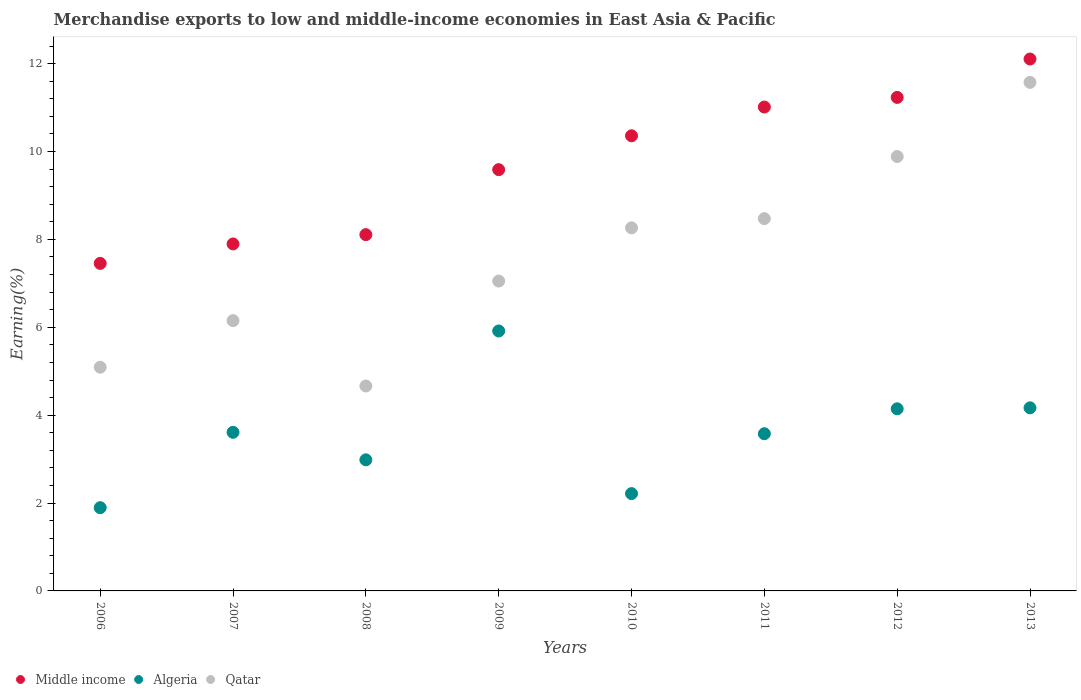Is the number of dotlines equal to the number of legend labels?
Provide a short and direct response. Yes. What is the percentage of amount earned from merchandise exports in Middle income in 2008?
Your answer should be compact. 8.11. Across all years, what is the maximum percentage of amount earned from merchandise exports in Algeria?
Provide a succinct answer. 5.92. Across all years, what is the minimum percentage of amount earned from merchandise exports in Algeria?
Your response must be concise. 1.9. In which year was the percentage of amount earned from merchandise exports in Algeria minimum?
Keep it short and to the point. 2006. What is the total percentage of amount earned from merchandise exports in Qatar in the graph?
Your answer should be compact. 61.16. What is the difference between the percentage of amount earned from merchandise exports in Algeria in 2012 and that in 2013?
Ensure brevity in your answer.  -0.02. What is the difference between the percentage of amount earned from merchandise exports in Qatar in 2007 and the percentage of amount earned from merchandise exports in Algeria in 2009?
Your response must be concise. 0.24. What is the average percentage of amount earned from merchandise exports in Qatar per year?
Keep it short and to the point. 7.64. In the year 2009, what is the difference between the percentage of amount earned from merchandise exports in Algeria and percentage of amount earned from merchandise exports in Qatar?
Your answer should be very brief. -1.14. In how many years, is the percentage of amount earned from merchandise exports in Algeria greater than 10.4 %?
Your answer should be very brief. 0. What is the ratio of the percentage of amount earned from merchandise exports in Middle income in 2009 to that in 2010?
Your answer should be very brief. 0.93. What is the difference between the highest and the second highest percentage of amount earned from merchandise exports in Middle income?
Keep it short and to the point. 0.87. What is the difference between the highest and the lowest percentage of amount earned from merchandise exports in Algeria?
Keep it short and to the point. 4.02. In how many years, is the percentage of amount earned from merchandise exports in Middle income greater than the average percentage of amount earned from merchandise exports in Middle income taken over all years?
Your answer should be very brief. 4. Is the sum of the percentage of amount earned from merchandise exports in Qatar in 2007 and 2013 greater than the maximum percentage of amount earned from merchandise exports in Algeria across all years?
Give a very brief answer. Yes. Is it the case that in every year, the sum of the percentage of amount earned from merchandise exports in Middle income and percentage of amount earned from merchandise exports in Qatar  is greater than the percentage of amount earned from merchandise exports in Algeria?
Your answer should be very brief. Yes. How many dotlines are there?
Make the answer very short. 3. How many years are there in the graph?
Your answer should be very brief. 8. Are the values on the major ticks of Y-axis written in scientific E-notation?
Provide a short and direct response. No. Does the graph contain grids?
Your response must be concise. No. Where does the legend appear in the graph?
Provide a short and direct response. Bottom left. What is the title of the graph?
Your response must be concise. Merchandise exports to low and middle-income economies in East Asia & Pacific. What is the label or title of the X-axis?
Ensure brevity in your answer.  Years. What is the label or title of the Y-axis?
Offer a very short reply. Earning(%). What is the Earning(%) of Middle income in 2006?
Keep it short and to the point. 7.45. What is the Earning(%) in Algeria in 2006?
Offer a very short reply. 1.9. What is the Earning(%) of Qatar in 2006?
Ensure brevity in your answer.  5.09. What is the Earning(%) in Middle income in 2007?
Provide a short and direct response. 7.9. What is the Earning(%) in Algeria in 2007?
Make the answer very short. 3.61. What is the Earning(%) in Qatar in 2007?
Provide a short and direct response. 6.15. What is the Earning(%) of Middle income in 2008?
Offer a terse response. 8.11. What is the Earning(%) of Algeria in 2008?
Make the answer very short. 2.98. What is the Earning(%) in Qatar in 2008?
Offer a terse response. 4.66. What is the Earning(%) of Middle income in 2009?
Keep it short and to the point. 9.59. What is the Earning(%) in Algeria in 2009?
Provide a short and direct response. 5.92. What is the Earning(%) of Qatar in 2009?
Provide a short and direct response. 7.05. What is the Earning(%) of Middle income in 2010?
Provide a short and direct response. 10.36. What is the Earning(%) in Algeria in 2010?
Keep it short and to the point. 2.21. What is the Earning(%) of Qatar in 2010?
Ensure brevity in your answer.  8.26. What is the Earning(%) in Middle income in 2011?
Ensure brevity in your answer.  11.01. What is the Earning(%) of Algeria in 2011?
Your answer should be very brief. 3.58. What is the Earning(%) of Qatar in 2011?
Provide a succinct answer. 8.47. What is the Earning(%) of Middle income in 2012?
Provide a succinct answer. 11.23. What is the Earning(%) of Algeria in 2012?
Make the answer very short. 4.15. What is the Earning(%) of Qatar in 2012?
Your answer should be compact. 9.89. What is the Earning(%) in Middle income in 2013?
Provide a short and direct response. 12.11. What is the Earning(%) in Algeria in 2013?
Your answer should be compact. 4.17. What is the Earning(%) in Qatar in 2013?
Give a very brief answer. 11.57. Across all years, what is the maximum Earning(%) in Middle income?
Offer a terse response. 12.11. Across all years, what is the maximum Earning(%) in Algeria?
Your response must be concise. 5.92. Across all years, what is the maximum Earning(%) in Qatar?
Your answer should be compact. 11.57. Across all years, what is the minimum Earning(%) in Middle income?
Your answer should be very brief. 7.45. Across all years, what is the minimum Earning(%) of Algeria?
Your answer should be compact. 1.9. Across all years, what is the minimum Earning(%) of Qatar?
Ensure brevity in your answer.  4.66. What is the total Earning(%) in Middle income in the graph?
Offer a very short reply. 77.76. What is the total Earning(%) in Algeria in the graph?
Provide a succinct answer. 28.51. What is the total Earning(%) in Qatar in the graph?
Provide a succinct answer. 61.16. What is the difference between the Earning(%) of Middle income in 2006 and that in 2007?
Offer a very short reply. -0.44. What is the difference between the Earning(%) of Algeria in 2006 and that in 2007?
Your response must be concise. -1.72. What is the difference between the Earning(%) in Qatar in 2006 and that in 2007?
Ensure brevity in your answer.  -1.06. What is the difference between the Earning(%) of Middle income in 2006 and that in 2008?
Ensure brevity in your answer.  -0.65. What is the difference between the Earning(%) in Algeria in 2006 and that in 2008?
Your answer should be very brief. -1.09. What is the difference between the Earning(%) of Qatar in 2006 and that in 2008?
Ensure brevity in your answer.  0.43. What is the difference between the Earning(%) of Middle income in 2006 and that in 2009?
Keep it short and to the point. -2.13. What is the difference between the Earning(%) of Algeria in 2006 and that in 2009?
Ensure brevity in your answer.  -4.02. What is the difference between the Earning(%) of Qatar in 2006 and that in 2009?
Provide a succinct answer. -1.96. What is the difference between the Earning(%) of Middle income in 2006 and that in 2010?
Your answer should be very brief. -2.9. What is the difference between the Earning(%) of Algeria in 2006 and that in 2010?
Your response must be concise. -0.32. What is the difference between the Earning(%) of Qatar in 2006 and that in 2010?
Your answer should be compact. -3.17. What is the difference between the Earning(%) in Middle income in 2006 and that in 2011?
Offer a terse response. -3.56. What is the difference between the Earning(%) of Algeria in 2006 and that in 2011?
Provide a succinct answer. -1.68. What is the difference between the Earning(%) in Qatar in 2006 and that in 2011?
Give a very brief answer. -3.38. What is the difference between the Earning(%) of Middle income in 2006 and that in 2012?
Make the answer very short. -3.78. What is the difference between the Earning(%) of Algeria in 2006 and that in 2012?
Provide a short and direct response. -2.25. What is the difference between the Earning(%) of Qatar in 2006 and that in 2012?
Keep it short and to the point. -4.8. What is the difference between the Earning(%) of Middle income in 2006 and that in 2013?
Offer a terse response. -4.65. What is the difference between the Earning(%) of Algeria in 2006 and that in 2013?
Your answer should be compact. -2.27. What is the difference between the Earning(%) in Qatar in 2006 and that in 2013?
Your response must be concise. -6.48. What is the difference between the Earning(%) of Middle income in 2007 and that in 2008?
Offer a very short reply. -0.21. What is the difference between the Earning(%) of Algeria in 2007 and that in 2008?
Ensure brevity in your answer.  0.63. What is the difference between the Earning(%) in Qatar in 2007 and that in 2008?
Keep it short and to the point. 1.49. What is the difference between the Earning(%) in Middle income in 2007 and that in 2009?
Keep it short and to the point. -1.69. What is the difference between the Earning(%) of Algeria in 2007 and that in 2009?
Provide a succinct answer. -2.31. What is the difference between the Earning(%) in Qatar in 2007 and that in 2009?
Your answer should be very brief. -0.9. What is the difference between the Earning(%) in Middle income in 2007 and that in 2010?
Make the answer very short. -2.46. What is the difference between the Earning(%) in Algeria in 2007 and that in 2010?
Give a very brief answer. 1.4. What is the difference between the Earning(%) of Qatar in 2007 and that in 2010?
Make the answer very short. -2.11. What is the difference between the Earning(%) of Middle income in 2007 and that in 2011?
Give a very brief answer. -3.12. What is the difference between the Earning(%) in Algeria in 2007 and that in 2011?
Offer a terse response. 0.03. What is the difference between the Earning(%) of Qatar in 2007 and that in 2011?
Provide a succinct answer. -2.32. What is the difference between the Earning(%) of Middle income in 2007 and that in 2012?
Ensure brevity in your answer.  -3.33. What is the difference between the Earning(%) in Algeria in 2007 and that in 2012?
Keep it short and to the point. -0.54. What is the difference between the Earning(%) of Qatar in 2007 and that in 2012?
Ensure brevity in your answer.  -3.74. What is the difference between the Earning(%) of Middle income in 2007 and that in 2013?
Make the answer very short. -4.21. What is the difference between the Earning(%) in Algeria in 2007 and that in 2013?
Your answer should be very brief. -0.56. What is the difference between the Earning(%) in Qatar in 2007 and that in 2013?
Provide a succinct answer. -5.42. What is the difference between the Earning(%) in Middle income in 2008 and that in 2009?
Your response must be concise. -1.48. What is the difference between the Earning(%) in Algeria in 2008 and that in 2009?
Give a very brief answer. -2.93. What is the difference between the Earning(%) in Qatar in 2008 and that in 2009?
Ensure brevity in your answer.  -2.39. What is the difference between the Earning(%) of Middle income in 2008 and that in 2010?
Your answer should be very brief. -2.25. What is the difference between the Earning(%) of Algeria in 2008 and that in 2010?
Make the answer very short. 0.77. What is the difference between the Earning(%) of Qatar in 2008 and that in 2010?
Your answer should be very brief. -3.6. What is the difference between the Earning(%) in Middle income in 2008 and that in 2011?
Offer a terse response. -2.9. What is the difference between the Earning(%) in Algeria in 2008 and that in 2011?
Your answer should be very brief. -0.59. What is the difference between the Earning(%) of Qatar in 2008 and that in 2011?
Your answer should be compact. -3.81. What is the difference between the Earning(%) of Middle income in 2008 and that in 2012?
Provide a short and direct response. -3.12. What is the difference between the Earning(%) in Algeria in 2008 and that in 2012?
Offer a terse response. -1.16. What is the difference between the Earning(%) in Qatar in 2008 and that in 2012?
Provide a short and direct response. -5.22. What is the difference between the Earning(%) of Middle income in 2008 and that in 2013?
Your answer should be compact. -4. What is the difference between the Earning(%) in Algeria in 2008 and that in 2013?
Provide a short and direct response. -1.18. What is the difference between the Earning(%) of Qatar in 2008 and that in 2013?
Your response must be concise. -6.91. What is the difference between the Earning(%) in Middle income in 2009 and that in 2010?
Offer a very short reply. -0.77. What is the difference between the Earning(%) in Algeria in 2009 and that in 2010?
Your answer should be very brief. 3.7. What is the difference between the Earning(%) in Qatar in 2009 and that in 2010?
Give a very brief answer. -1.21. What is the difference between the Earning(%) in Middle income in 2009 and that in 2011?
Provide a succinct answer. -1.42. What is the difference between the Earning(%) of Algeria in 2009 and that in 2011?
Give a very brief answer. 2.34. What is the difference between the Earning(%) of Qatar in 2009 and that in 2011?
Provide a succinct answer. -1.42. What is the difference between the Earning(%) of Middle income in 2009 and that in 2012?
Offer a very short reply. -1.64. What is the difference between the Earning(%) in Algeria in 2009 and that in 2012?
Your response must be concise. 1.77. What is the difference between the Earning(%) of Qatar in 2009 and that in 2012?
Your answer should be compact. -2.83. What is the difference between the Earning(%) in Middle income in 2009 and that in 2013?
Ensure brevity in your answer.  -2.52. What is the difference between the Earning(%) of Algeria in 2009 and that in 2013?
Your answer should be very brief. 1.75. What is the difference between the Earning(%) in Qatar in 2009 and that in 2013?
Ensure brevity in your answer.  -4.52. What is the difference between the Earning(%) in Middle income in 2010 and that in 2011?
Ensure brevity in your answer.  -0.65. What is the difference between the Earning(%) of Algeria in 2010 and that in 2011?
Make the answer very short. -1.36. What is the difference between the Earning(%) in Qatar in 2010 and that in 2011?
Keep it short and to the point. -0.21. What is the difference between the Earning(%) in Middle income in 2010 and that in 2012?
Keep it short and to the point. -0.87. What is the difference between the Earning(%) of Algeria in 2010 and that in 2012?
Provide a succinct answer. -1.93. What is the difference between the Earning(%) in Qatar in 2010 and that in 2012?
Your response must be concise. -1.62. What is the difference between the Earning(%) of Middle income in 2010 and that in 2013?
Provide a short and direct response. -1.75. What is the difference between the Earning(%) in Algeria in 2010 and that in 2013?
Offer a very short reply. -1.95. What is the difference between the Earning(%) of Qatar in 2010 and that in 2013?
Your answer should be very brief. -3.31. What is the difference between the Earning(%) of Middle income in 2011 and that in 2012?
Your response must be concise. -0.22. What is the difference between the Earning(%) of Algeria in 2011 and that in 2012?
Keep it short and to the point. -0.57. What is the difference between the Earning(%) in Qatar in 2011 and that in 2012?
Ensure brevity in your answer.  -1.41. What is the difference between the Earning(%) of Middle income in 2011 and that in 2013?
Offer a very short reply. -1.09. What is the difference between the Earning(%) in Algeria in 2011 and that in 2013?
Offer a very short reply. -0.59. What is the difference between the Earning(%) in Qatar in 2011 and that in 2013?
Offer a terse response. -3.1. What is the difference between the Earning(%) in Middle income in 2012 and that in 2013?
Provide a succinct answer. -0.87. What is the difference between the Earning(%) in Algeria in 2012 and that in 2013?
Provide a succinct answer. -0.02. What is the difference between the Earning(%) of Qatar in 2012 and that in 2013?
Offer a terse response. -1.69. What is the difference between the Earning(%) in Middle income in 2006 and the Earning(%) in Algeria in 2007?
Provide a succinct answer. 3.84. What is the difference between the Earning(%) in Middle income in 2006 and the Earning(%) in Qatar in 2007?
Provide a short and direct response. 1.3. What is the difference between the Earning(%) in Algeria in 2006 and the Earning(%) in Qatar in 2007?
Your answer should be very brief. -4.26. What is the difference between the Earning(%) in Middle income in 2006 and the Earning(%) in Algeria in 2008?
Offer a very short reply. 4.47. What is the difference between the Earning(%) in Middle income in 2006 and the Earning(%) in Qatar in 2008?
Ensure brevity in your answer.  2.79. What is the difference between the Earning(%) of Algeria in 2006 and the Earning(%) of Qatar in 2008?
Your answer should be compact. -2.77. What is the difference between the Earning(%) of Middle income in 2006 and the Earning(%) of Algeria in 2009?
Make the answer very short. 1.54. What is the difference between the Earning(%) of Middle income in 2006 and the Earning(%) of Qatar in 2009?
Provide a succinct answer. 0.4. What is the difference between the Earning(%) of Algeria in 2006 and the Earning(%) of Qatar in 2009?
Keep it short and to the point. -5.16. What is the difference between the Earning(%) of Middle income in 2006 and the Earning(%) of Algeria in 2010?
Offer a terse response. 5.24. What is the difference between the Earning(%) of Middle income in 2006 and the Earning(%) of Qatar in 2010?
Keep it short and to the point. -0.81. What is the difference between the Earning(%) in Algeria in 2006 and the Earning(%) in Qatar in 2010?
Your answer should be compact. -6.37. What is the difference between the Earning(%) of Middle income in 2006 and the Earning(%) of Algeria in 2011?
Your response must be concise. 3.88. What is the difference between the Earning(%) in Middle income in 2006 and the Earning(%) in Qatar in 2011?
Provide a short and direct response. -1.02. What is the difference between the Earning(%) of Algeria in 2006 and the Earning(%) of Qatar in 2011?
Your answer should be compact. -6.58. What is the difference between the Earning(%) of Middle income in 2006 and the Earning(%) of Algeria in 2012?
Your response must be concise. 3.31. What is the difference between the Earning(%) of Middle income in 2006 and the Earning(%) of Qatar in 2012?
Provide a succinct answer. -2.43. What is the difference between the Earning(%) in Algeria in 2006 and the Earning(%) in Qatar in 2012?
Your response must be concise. -7.99. What is the difference between the Earning(%) in Middle income in 2006 and the Earning(%) in Algeria in 2013?
Offer a terse response. 3.29. What is the difference between the Earning(%) of Middle income in 2006 and the Earning(%) of Qatar in 2013?
Offer a very short reply. -4.12. What is the difference between the Earning(%) of Algeria in 2006 and the Earning(%) of Qatar in 2013?
Ensure brevity in your answer.  -9.68. What is the difference between the Earning(%) of Middle income in 2007 and the Earning(%) of Algeria in 2008?
Ensure brevity in your answer.  4.91. What is the difference between the Earning(%) of Middle income in 2007 and the Earning(%) of Qatar in 2008?
Give a very brief answer. 3.23. What is the difference between the Earning(%) in Algeria in 2007 and the Earning(%) in Qatar in 2008?
Give a very brief answer. -1.05. What is the difference between the Earning(%) of Middle income in 2007 and the Earning(%) of Algeria in 2009?
Your answer should be very brief. 1.98. What is the difference between the Earning(%) in Middle income in 2007 and the Earning(%) in Qatar in 2009?
Provide a succinct answer. 0.84. What is the difference between the Earning(%) of Algeria in 2007 and the Earning(%) of Qatar in 2009?
Your response must be concise. -3.44. What is the difference between the Earning(%) of Middle income in 2007 and the Earning(%) of Algeria in 2010?
Provide a succinct answer. 5.68. What is the difference between the Earning(%) in Middle income in 2007 and the Earning(%) in Qatar in 2010?
Make the answer very short. -0.37. What is the difference between the Earning(%) in Algeria in 2007 and the Earning(%) in Qatar in 2010?
Make the answer very short. -4.65. What is the difference between the Earning(%) in Middle income in 2007 and the Earning(%) in Algeria in 2011?
Keep it short and to the point. 4.32. What is the difference between the Earning(%) in Middle income in 2007 and the Earning(%) in Qatar in 2011?
Ensure brevity in your answer.  -0.58. What is the difference between the Earning(%) in Algeria in 2007 and the Earning(%) in Qatar in 2011?
Your answer should be very brief. -4.86. What is the difference between the Earning(%) in Middle income in 2007 and the Earning(%) in Algeria in 2012?
Your answer should be compact. 3.75. What is the difference between the Earning(%) of Middle income in 2007 and the Earning(%) of Qatar in 2012?
Your answer should be compact. -1.99. What is the difference between the Earning(%) of Algeria in 2007 and the Earning(%) of Qatar in 2012?
Provide a succinct answer. -6.28. What is the difference between the Earning(%) of Middle income in 2007 and the Earning(%) of Algeria in 2013?
Provide a short and direct response. 3.73. What is the difference between the Earning(%) of Middle income in 2007 and the Earning(%) of Qatar in 2013?
Your answer should be compact. -3.68. What is the difference between the Earning(%) of Algeria in 2007 and the Earning(%) of Qatar in 2013?
Your answer should be compact. -7.96. What is the difference between the Earning(%) of Middle income in 2008 and the Earning(%) of Algeria in 2009?
Provide a short and direct response. 2.19. What is the difference between the Earning(%) of Middle income in 2008 and the Earning(%) of Qatar in 2009?
Offer a terse response. 1.06. What is the difference between the Earning(%) of Algeria in 2008 and the Earning(%) of Qatar in 2009?
Make the answer very short. -4.07. What is the difference between the Earning(%) of Middle income in 2008 and the Earning(%) of Algeria in 2010?
Your answer should be very brief. 5.89. What is the difference between the Earning(%) of Middle income in 2008 and the Earning(%) of Qatar in 2010?
Your response must be concise. -0.15. What is the difference between the Earning(%) in Algeria in 2008 and the Earning(%) in Qatar in 2010?
Make the answer very short. -5.28. What is the difference between the Earning(%) in Middle income in 2008 and the Earning(%) in Algeria in 2011?
Ensure brevity in your answer.  4.53. What is the difference between the Earning(%) in Middle income in 2008 and the Earning(%) in Qatar in 2011?
Make the answer very short. -0.36. What is the difference between the Earning(%) in Algeria in 2008 and the Earning(%) in Qatar in 2011?
Your answer should be compact. -5.49. What is the difference between the Earning(%) of Middle income in 2008 and the Earning(%) of Algeria in 2012?
Provide a short and direct response. 3.96. What is the difference between the Earning(%) in Middle income in 2008 and the Earning(%) in Qatar in 2012?
Keep it short and to the point. -1.78. What is the difference between the Earning(%) of Algeria in 2008 and the Earning(%) of Qatar in 2012?
Make the answer very short. -6.9. What is the difference between the Earning(%) of Middle income in 2008 and the Earning(%) of Algeria in 2013?
Offer a terse response. 3.94. What is the difference between the Earning(%) of Middle income in 2008 and the Earning(%) of Qatar in 2013?
Offer a terse response. -3.47. What is the difference between the Earning(%) in Algeria in 2008 and the Earning(%) in Qatar in 2013?
Your response must be concise. -8.59. What is the difference between the Earning(%) in Middle income in 2009 and the Earning(%) in Algeria in 2010?
Provide a short and direct response. 7.37. What is the difference between the Earning(%) of Middle income in 2009 and the Earning(%) of Qatar in 2010?
Offer a terse response. 1.32. What is the difference between the Earning(%) in Algeria in 2009 and the Earning(%) in Qatar in 2010?
Offer a terse response. -2.35. What is the difference between the Earning(%) of Middle income in 2009 and the Earning(%) of Algeria in 2011?
Give a very brief answer. 6.01. What is the difference between the Earning(%) in Middle income in 2009 and the Earning(%) in Qatar in 2011?
Give a very brief answer. 1.12. What is the difference between the Earning(%) in Algeria in 2009 and the Earning(%) in Qatar in 2011?
Give a very brief answer. -2.56. What is the difference between the Earning(%) of Middle income in 2009 and the Earning(%) of Algeria in 2012?
Offer a very short reply. 5.44. What is the difference between the Earning(%) of Middle income in 2009 and the Earning(%) of Qatar in 2012?
Give a very brief answer. -0.3. What is the difference between the Earning(%) of Algeria in 2009 and the Earning(%) of Qatar in 2012?
Your answer should be very brief. -3.97. What is the difference between the Earning(%) of Middle income in 2009 and the Earning(%) of Algeria in 2013?
Provide a short and direct response. 5.42. What is the difference between the Earning(%) in Middle income in 2009 and the Earning(%) in Qatar in 2013?
Make the answer very short. -1.99. What is the difference between the Earning(%) in Algeria in 2009 and the Earning(%) in Qatar in 2013?
Provide a succinct answer. -5.66. What is the difference between the Earning(%) in Middle income in 2010 and the Earning(%) in Algeria in 2011?
Give a very brief answer. 6.78. What is the difference between the Earning(%) of Middle income in 2010 and the Earning(%) of Qatar in 2011?
Offer a terse response. 1.89. What is the difference between the Earning(%) of Algeria in 2010 and the Earning(%) of Qatar in 2011?
Give a very brief answer. -6.26. What is the difference between the Earning(%) in Middle income in 2010 and the Earning(%) in Algeria in 2012?
Your answer should be compact. 6.21. What is the difference between the Earning(%) in Middle income in 2010 and the Earning(%) in Qatar in 2012?
Make the answer very short. 0.47. What is the difference between the Earning(%) of Algeria in 2010 and the Earning(%) of Qatar in 2012?
Offer a very short reply. -7.67. What is the difference between the Earning(%) of Middle income in 2010 and the Earning(%) of Algeria in 2013?
Your response must be concise. 6.19. What is the difference between the Earning(%) of Middle income in 2010 and the Earning(%) of Qatar in 2013?
Provide a succinct answer. -1.22. What is the difference between the Earning(%) in Algeria in 2010 and the Earning(%) in Qatar in 2013?
Your answer should be very brief. -9.36. What is the difference between the Earning(%) of Middle income in 2011 and the Earning(%) of Algeria in 2012?
Ensure brevity in your answer.  6.87. What is the difference between the Earning(%) of Middle income in 2011 and the Earning(%) of Qatar in 2012?
Give a very brief answer. 1.13. What is the difference between the Earning(%) of Algeria in 2011 and the Earning(%) of Qatar in 2012?
Give a very brief answer. -6.31. What is the difference between the Earning(%) of Middle income in 2011 and the Earning(%) of Algeria in 2013?
Give a very brief answer. 6.85. What is the difference between the Earning(%) in Middle income in 2011 and the Earning(%) in Qatar in 2013?
Ensure brevity in your answer.  -0.56. What is the difference between the Earning(%) in Algeria in 2011 and the Earning(%) in Qatar in 2013?
Make the answer very short. -8. What is the difference between the Earning(%) of Middle income in 2012 and the Earning(%) of Algeria in 2013?
Your response must be concise. 7.06. What is the difference between the Earning(%) in Middle income in 2012 and the Earning(%) in Qatar in 2013?
Provide a short and direct response. -0.34. What is the difference between the Earning(%) of Algeria in 2012 and the Earning(%) of Qatar in 2013?
Your answer should be very brief. -7.43. What is the average Earning(%) of Middle income per year?
Your answer should be very brief. 9.72. What is the average Earning(%) in Algeria per year?
Provide a succinct answer. 3.56. What is the average Earning(%) of Qatar per year?
Your answer should be compact. 7.64. In the year 2006, what is the difference between the Earning(%) of Middle income and Earning(%) of Algeria?
Keep it short and to the point. 5.56. In the year 2006, what is the difference between the Earning(%) of Middle income and Earning(%) of Qatar?
Make the answer very short. 2.36. In the year 2006, what is the difference between the Earning(%) of Algeria and Earning(%) of Qatar?
Give a very brief answer. -3.2. In the year 2007, what is the difference between the Earning(%) in Middle income and Earning(%) in Algeria?
Your answer should be compact. 4.29. In the year 2007, what is the difference between the Earning(%) in Middle income and Earning(%) in Qatar?
Your answer should be compact. 1.75. In the year 2007, what is the difference between the Earning(%) of Algeria and Earning(%) of Qatar?
Your answer should be very brief. -2.54. In the year 2008, what is the difference between the Earning(%) of Middle income and Earning(%) of Algeria?
Offer a terse response. 5.12. In the year 2008, what is the difference between the Earning(%) of Middle income and Earning(%) of Qatar?
Give a very brief answer. 3.44. In the year 2008, what is the difference between the Earning(%) of Algeria and Earning(%) of Qatar?
Provide a short and direct response. -1.68. In the year 2009, what is the difference between the Earning(%) of Middle income and Earning(%) of Algeria?
Keep it short and to the point. 3.67. In the year 2009, what is the difference between the Earning(%) in Middle income and Earning(%) in Qatar?
Provide a short and direct response. 2.54. In the year 2009, what is the difference between the Earning(%) in Algeria and Earning(%) in Qatar?
Your answer should be compact. -1.14. In the year 2010, what is the difference between the Earning(%) in Middle income and Earning(%) in Algeria?
Your answer should be compact. 8.14. In the year 2010, what is the difference between the Earning(%) in Middle income and Earning(%) in Qatar?
Give a very brief answer. 2.1. In the year 2010, what is the difference between the Earning(%) of Algeria and Earning(%) of Qatar?
Ensure brevity in your answer.  -6.05. In the year 2011, what is the difference between the Earning(%) in Middle income and Earning(%) in Algeria?
Make the answer very short. 7.44. In the year 2011, what is the difference between the Earning(%) of Middle income and Earning(%) of Qatar?
Your response must be concise. 2.54. In the year 2011, what is the difference between the Earning(%) in Algeria and Earning(%) in Qatar?
Ensure brevity in your answer.  -4.9. In the year 2012, what is the difference between the Earning(%) in Middle income and Earning(%) in Algeria?
Give a very brief answer. 7.09. In the year 2012, what is the difference between the Earning(%) in Middle income and Earning(%) in Qatar?
Ensure brevity in your answer.  1.35. In the year 2012, what is the difference between the Earning(%) of Algeria and Earning(%) of Qatar?
Ensure brevity in your answer.  -5.74. In the year 2013, what is the difference between the Earning(%) of Middle income and Earning(%) of Algeria?
Your response must be concise. 7.94. In the year 2013, what is the difference between the Earning(%) of Middle income and Earning(%) of Qatar?
Ensure brevity in your answer.  0.53. In the year 2013, what is the difference between the Earning(%) in Algeria and Earning(%) in Qatar?
Make the answer very short. -7.41. What is the ratio of the Earning(%) of Middle income in 2006 to that in 2007?
Give a very brief answer. 0.94. What is the ratio of the Earning(%) in Algeria in 2006 to that in 2007?
Provide a short and direct response. 0.52. What is the ratio of the Earning(%) in Qatar in 2006 to that in 2007?
Offer a terse response. 0.83. What is the ratio of the Earning(%) in Middle income in 2006 to that in 2008?
Keep it short and to the point. 0.92. What is the ratio of the Earning(%) in Algeria in 2006 to that in 2008?
Your answer should be very brief. 0.64. What is the ratio of the Earning(%) of Qatar in 2006 to that in 2008?
Your response must be concise. 1.09. What is the ratio of the Earning(%) of Middle income in 2006 to that in 2009?
Offer a very short reply. 0.78. What is the ratio of the Earning(%) of Algeria in 2006 to that in 2009?
Make the answer very short. 0.32. What is the ratio of the Earning(%) of Qatar in 2006 to that in 2009?
Your response must be concise. 0.72. What is the ratio of the Earning(%) of Middle income in 2006 to that in 2010?
Provide a succinct answer. 0.72. What is the ratio of the Earning(%) in Algeria in 2006 to that in 2010?
Give a very brief answer. 0.86. What is the ratio of the Earning(%) of Qatar in 2006 to that in 2010?
Ensure brevity in your answer.  0.62. What is the ratio of the Earning(%) in Middle income in 2006 to that in 2011?
Provide a short and direct response. 0.68. What is the ratio of the Earning(%) of Algeria in 2006 to that in 2011?
Give a very brief answer. 0.53. What is the ratio of the Earning(%) of Qatar in 2006 to that in 2011?
Your response must be concise. 0.6. What is the ratio of the Earning(%) of Middle income in 2006 to that in 2012?
Offer a terse response. 0.66. What is the ratio of the Earning(%) in Algeria in 2006 to that in 2012?
Keep it short and to the point. 0.46. What is the ratio of the Earning(%) in Qatar in 2006 to that in 2012?
Provide a short and direct response. 0.52. What is the ratio of the Earning(%) in Middle income in 2006 to that in 2013?
Your response must be concise. 0.62. What is the ratio of the Earning(%) in Algeria in 2006 to that in 2013?
Provide a succinct answer. 0.45. What is the ratio of the Earning(%) of Qatar in 2006 to that in 2013?
Keep it short and to the point. 0.44. What is the ratio of the Earning(%) in Middle income in 2007 to that in 2008?
Offer a terse response. 0.97. What is the ratio of the Earning(%) of Algeria in 2007 to that in 2008?
Provide a short and direct response. 1.21. What is the ratio of the Earning(%) of Qatar in 2007 to that in 2008?
Provide a succinct answer. 1.32. What is the ratio of the Earning(%) of Middle income in 2007 to that in 2009?
Offer a terse response. 0.82. What is the ratio of the Earning(%) of Algeria in 2007 to that in 2009?
Your response must be concise. 0.61. What is the ratio of the Earning(%) of Qatar in 2007 to that in 2009?
Your answer should be compact. 0.87. What is the ratio of the Earning(%) of Middle income in 2007 to that in 2010?
Provide a succinct answer. 0.76. What is the ratio of the Earning(%) in Algeria in 2007 to that in 2010?
Your answer should be compact. 1.63. What is the ratio of the Earning(%) of Qatar in 2007 to that in 2010?
Make the answer very short. 0.74. What is the ratio of the Earning(%) of Middle income in 2007 to that in 2011?
Your answer should be compact. 0.72. What is the ratio of the Earning(%) of Algeria in 2007 to that in 2011?
Your response must be concise. 1.01. What is the ratio of the Earning(%) in Qatar in 2007 to that in 2011?
Provide a succinct answer. 0.73. What is the ratio of the Earning(%) of Middle income in 2007 to that in 2012?
Offer a very short reply. 0.7. What is the ratio of the Earning(%) of Algeria in 2007 to that in 2012?
Offer a very short reply. 0.87. What is the ratio of the Earning(%) in Qatar in 2007 to that in 2012?
Your response must be concise. 0.62. What is the ratio of the Earning(%) in Middle income in 2007 to that in 2013?
Offer a very short reply. 0.65. What is the ratio of the Earning(%) of Algeria in 2007 to that in 2013?
Your answer should be compact. 0.87. What is the ratio of the Earning(%) of Qatar in 2007 to that in 2013?
Offer a terse response. 0.53. What is the ratio of the Earning(%) in Middle income in 2008 to that in 2009?
Provide a short and direct response. 0.85. What is the ratio of the Earning(%) of Algeria in 2008 to that in 2009?
Make the answer very short. 0.5. What is the ratio of the Earning(%) in Qatar in 2008 to that in 2009?
Your response must be concise. 0.66. What is the ratio of the Earning(%) in Middle income in 2008 to that in 2010?
Provide a succinct answer. 0.78. What is the ratio of the Earning(%) in Algeria in 2008 to that in 2010?
Ensure brevity in your answer.  1.35. What is the ratio of the Earning(%) of Qatar in 2008 to that in 2010?
Keep it short and to the point. 0.56. What is the ratio of the Earning(%) of Middle income in 2008 to that in 2011?
Offer a terse response. 0.74. What is the ratio of the Earning(%) in Algeria in 2008 to that in 2011?
Keep it short and to the point. 0.83. What is the ratio of the Earning(%) in Qatar in 2008 to that in 2011?
Make the answer very short. 0.55. What is the ratio of the Earning(%) in Middle income in 2008 to that in 2012?
Your response must be concise. 0.72. What is the ratio of the Earning(%) in Algeria in 2008 to that in 2012?
Give a very brief answer. 0.72. What is the ratio of the Earning(%) of Qatar in 2008 to that in 2012?
Provide a short and direct response. 0.47. What is the ratio of the Earning(%) in Middle income in 2008 to that in 2013?
Offer a terse response. 0.67. What is the ratio of the Earning(%) in Algeria in 2008 to that in 2013?
Your answer should be compact. 0.72. What is the ratio of the Earning(%) in Qatar in 2008 to that in 2013?
Your answer should be very brief. 0.4. What is the ratio of the Earning(%) in Middle income in 2009 to that in 2010?
Provide a short and direct response. 0.93. What is the ratio of the Earning(%) in Algeria in 2009 to that in 2010?
Offer a very short reply. 2.67. What is the ratio of the Earning(%) of Qatar in 2009 to that in 2010?
Offer a terse response. 0.85. What is the ratio of the Earning(%) of Middle income in 2009 to that in 2011?
Your answer should be very brief. 0.87. What is the ratio of the Earning(%) of Algeria in 2009 to that in 2011?
Your answer should be compact. 1.65. What is the ratio of the Earning(%) of Qatar in 2009 to that in 2011?
Make the answer very short. 0.83. What is the ratio of the Earning(%) of Middle income in 2009 to that in 2012?
Your answer should be very brief. 0.85. What is the ratio of the Earning(%) in Algeria in 2009 to that in 2012?
Give a very brief answer. 1.43. What is the ratio of the Earning(%) in Qatar in 2009 to that in 2012?
Offer a very short reply. 0.71. What is the ratio of the Earning(%) of Middle income in 2009 to that in 2013?
Your response must be concise. 0.79. What is the ratio of the Earning(%) in Algeria in 2009 to that in 2013?
Keep it short and to the point. 1.42. What is the ratio of the Earning(%) in Qatar in 2009 to that in 2013?
Ensure brevity in your answer.  0.61. What is the ratio of the Earning(%) of Middle income in 2010 to that in 2011?
Give a very brief answer. 0.94. What is the ratio of the Earning(%) in Algeria in 2010 to that in 2011?
Give a very brief answer. 0.62. What is the ratio of the Earning(%) of Qatar in 2010 to that in 2011?
Keep it short and to the point. 0.98. What is the ratio of the Earning(%) of Middle income in 2010 to that in 2012?
Keep it short and to the point. 0.92. What is the ratio of the Earning(%) in Algeria in 2010 to that in 2012?
Provide a succinct answer. 0.53. What is the ratio of the Earning(%) in Qatar in 2010 to that in 2012?
Provide a short and direct response. 0.84. What is the ratio of the Earning(%) of Middle income in 2010 to that in 2013?
Provide a short and direct response. 0.86. What is the ratio of the Earning(%) in Algeria in 2010 to that in 2013?
Provide a short and direct response. 0.53. What is the ratio of the Earning(%) in Qatar in 2010 to that in 2013?
Make the answer very short. 0.71. What is the ratio of the Earning(%) of Middle income in 2011 to that in 2012?
Your answer should be very brief. 0.98. What is the ratio of the Earning(%) of Algeria in 2011 to that in 2012?
Ensure brevity in your answer.  0.86. What is the ratio of the Earning(%) of Qatar in 2011 to that in 2012?
Keep it short and to the point. 0.86. What is the ratio of the Earning(%) in Middle income in 2011 to that in 2013?
Offer a terse response. 0.91. What is the ratio of the Earning(%) of Algeria in 2011 to that in 2013?
Provide a short and direct response. 0.86. What is the ratio of the Earning(%) of Qatar in 2011 to that in 2013?
Your answer should be compact. 0.73. What is the ratio of the Earning(%) in Middle income in 2012 to that in 2013?
Offer a terse response. 0.93. What is the ratio of the Earning(%) of Algeria in 2012 to that in 2013?
Make the answer very short. 0.99. What is the ratio of the Earning(%) in Qatar in 2012 to that in 2013?
Make the answer very short. 0.85. What is the difference between the highest and the second highest Earning(%) of Middle income?
Ensure brevity in your answer.  0.87. What is the difference between the highest and the second highest Earning(%) of Algeria?
Ensure brevity in your answer.  1.75. What is the difference between the highest and the second highest Earning(%) of Qatar?
Offer a very short reply. 1.69. What is the difference between the highest and the lowest Earning(%) of Middle income?
Make the answer very short. 4.65. What is the difference between the highest and the lowest Earning(%) of Algeria?
Your answer should be very brief. 4.02. What is the difference between the highest and the lowest Earning(%) of Qatar?
Keep it short and to the point. 6.91. 